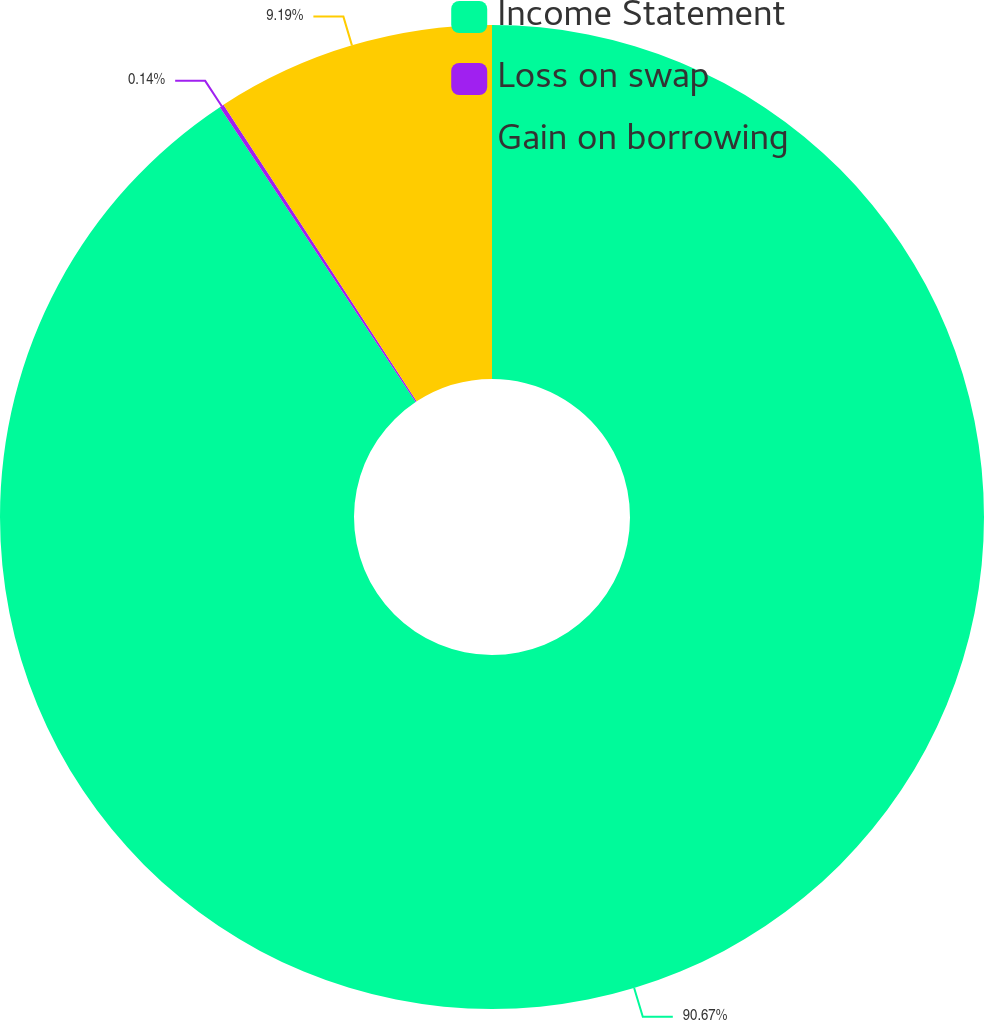Convert chart. <chart><loc_0><loc_0><loc_500><loc_500><pie_chart><fcel>Income Statement<fcel>Loss on swap<fcel>Gain on borrowing<nl><fcel>90.68%<fcel>0.14%<fcel>9.19%<nl></chart> 